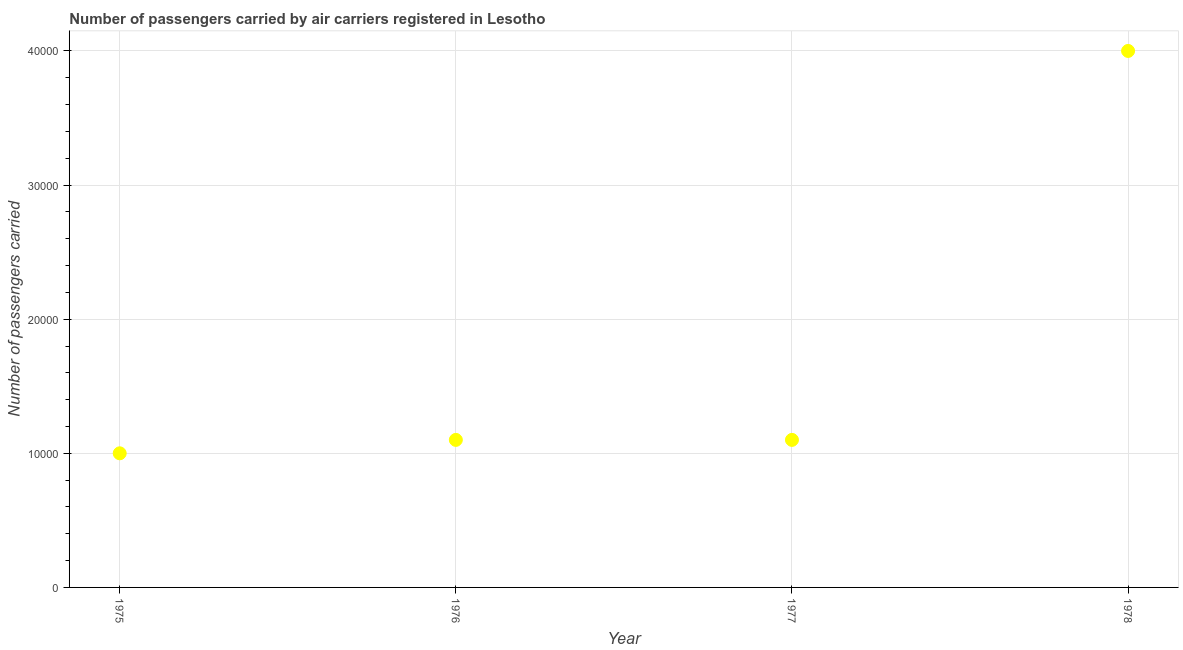What is the number of passengers carried in 1975?
Provide a succinct answer. 10000. Across all years, what is the maximum number of passengers carried?
Provide a short and direct response. 4.00e+04. Across all years, what is the minimum number of passengers carried?
Offer a terse response. 10000. In which year was the number of passengers carried maximum?
Ensure brevity in your answer.  1978. In which year was the number of passengers carried minimum?
Give a very brief answer. 1975. What is the sum of the number of passengers carried?
Offer a terse response. 7.20e+04. What is the difference between the number of passengers carried in 1976 and 1977?
Offer a very short reply. 0. What is the average number of passengers carried per year?
Your answer should be very brief. 1.80e+04. What is the median number of passengers carried?
Provide a succinct answer. 1.10e+04. Is the number of passengers carried in 1975 less than that in 1978?
Your answer should be very brief. Yes. What is the difference between the highest and the second highest number of passengers carried?
Make the answer very short. 2.90e+04. What is the difference between the highest and the lowest number of passengers carried?
Give a very brief answer. 3.00e+04. What is the difference between two consecutive major ticks on the Y-axis?
Ensure brevity in your answer.  10000. What is the title of the graph?
Offer a very short reply. Number of passengers carried by air carriers registered in Lesotho. What is the label or title of the Y-axis?
Offer a terse response. Number of passengers carried. What is the Number of passengers carried in 1975?
Offer a terse response. 10000. What is the Number of passengers carried in 1976?
Your response must be concise. 1.10e+04. What is the Number of passengers carried in 1977?
Your answer should be compact. 1.10e+04. What is the Number of passengers carried in 1978?
Ensure brevity in your answer.  4.00e+04. What is the difference between the Number of passengers carried in 1975 and 1976?
Your answer should be very brief. -1000. What is the difference between the Number of passengers carried in 1975 and 1977?
Give a very brief answer. -1000. What is the difference between the Number of passengers carried in 1976 and 1978?
Your answer should be compact. -2.90e+04. What is the difference between the Number of passengers carried in 1977 and 1978?
Your response must be concise. -2.90e+04. What is the ratio of the Number of passengers carried in 1975 to that in 1976?
Give a very brief answer. 0.91. What is the ratio of the Number of passengers carried in 1975 to that in 1977?
Ensure brevity in your answer.  0.91. What is the ratio of the Number of passengers carried in 1976 to that in 1977?
Keep it short and to the point. 1. What is the ratio of the Number of passengers carried in 1976 to that in 1978?
Ensure brevity in your answer.  0.28. What is the ratio of the Number of passengers carried in 1977 to that in 1978?
Your answer should be compact. 0.28. 